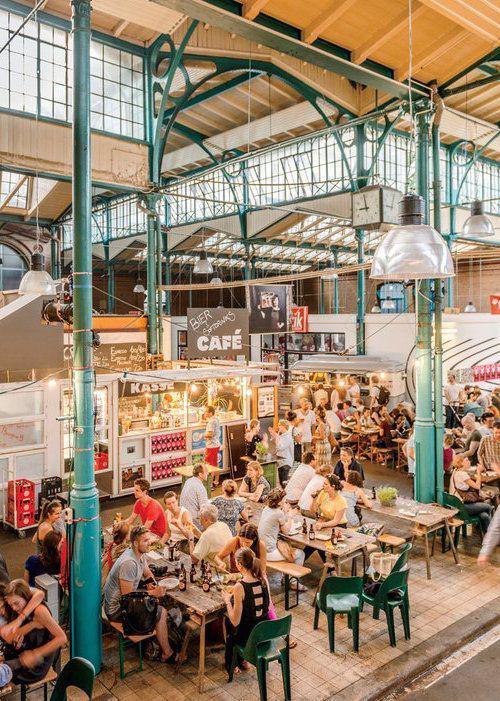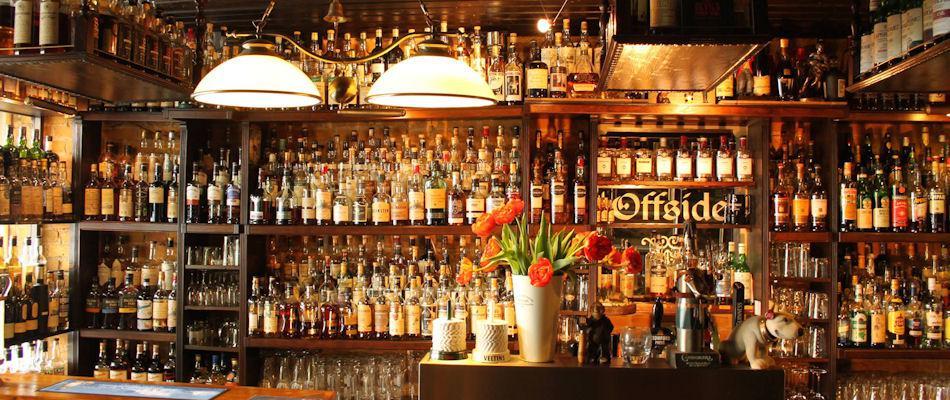The first image is the image on the left, the second image is the image on the right. Examine the images to the left and right. Is the description "In at least one of the images all the chairs are empty." accurate? Answer yes or no. No. 